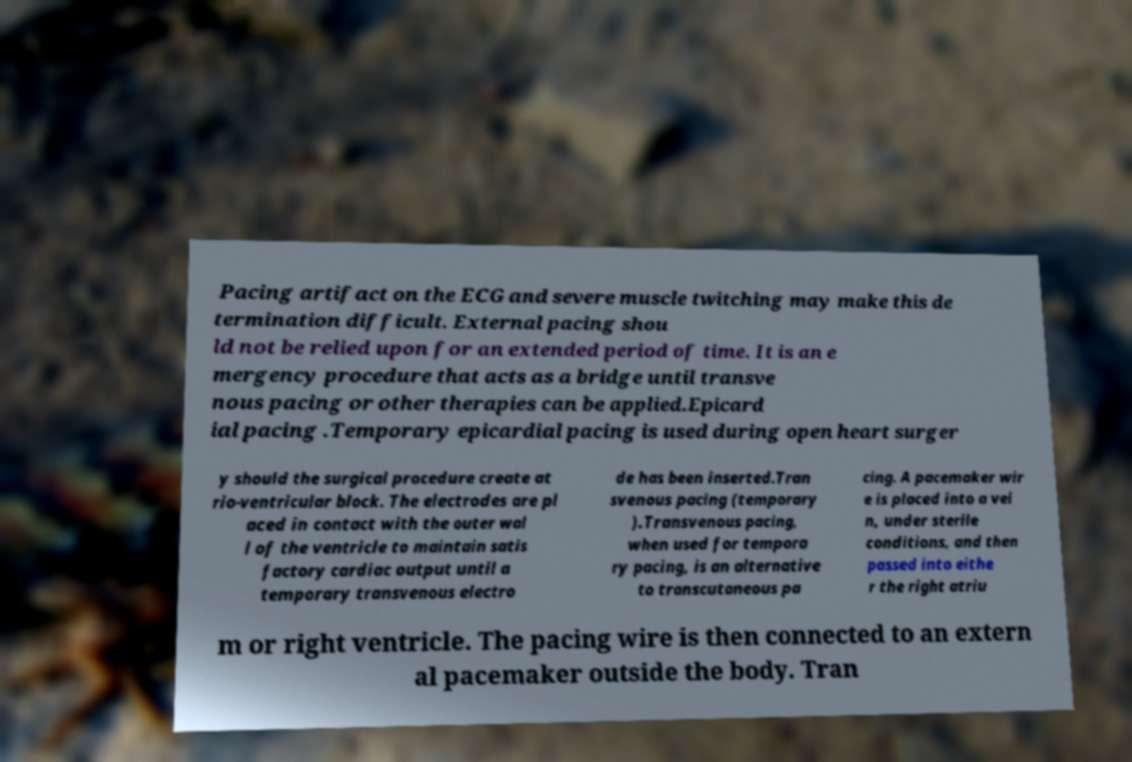Could you extract and type out the text from this image? Pacing artifact on the ECG and severe muscle twitching may make this de termination difficult. External pacing shou ld not be relied upon for an extended period of time. It is an e mergency procedure that acts as a bridge until transve nous pacing or other therapies can be applied.Epicard ial pacing .Temporary epicardial pacing is used during open heart surger y should the surgical procedure create at rio-ventricular block. The electrodes are pl aced in contact with the outer wal l of the ventricle to maintain satis factory cardiac output until a temporary transvenous electro de has been inserted.Tran svenous pacing (temporary ).Transvenous pacing, when used for tempora ry pacing, is an alternative to transcutaneous pa cing. A pacemaker wir e is placed into a vei n, under sterile conditions, and then passed into eithe r the right atriu m or right ventricle. The pacing wire is then connected to an extern al pacemaker outside the body. Tran 